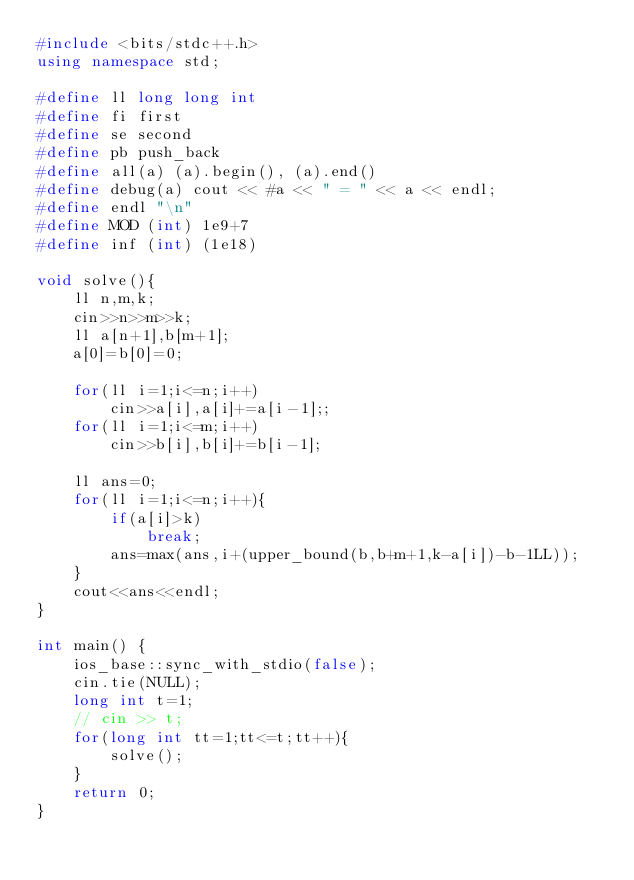<code> <loc_0><loc_0><loc_500><loc_500><_C++_>#include <bits/stdc++.h>
using namespace std;

#define ll long long int
#define fi first
#define se second
#define pb push_back
#define all(a) (a).begin(), (a).end()
#define debug(a) cout << #a << " = " << a << endl;
#define endl "\n"
#define MOD (int) 1e9+7
#define inf (int) (1e18)

void solve(){
    ll n,m,k;
    cin>>n>>m>>k;
    ll a[n+1],b[m+1];
    a[0]=b[0]=0;

    for(ll i=1;i<=n;i++)
        cin>>a[i],a[i]+=a[i-1];;
    for(ll i=1;i<=m;i++)
        cin>>b[i],b[i]+=b[i-1];

    ll ans=0;
    for(ll i=1;i<=n;i++){
        if(a[i]>k)
            break;
        ans=max(ans,i+(upper_bound(b,b+m+1,k-a[i])-b-1LL));
    }
    cout<<ans<<endl;
}

int main() {
    ios_base::sync_with_stdio(false);
    cin.tie(NULL);
    long int t=1;
    // cin >> t;
    for(long int tt=1;tt<=t;tt++){
        solve();
    }
    return 0;
}</code> 